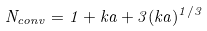Convert formula to latex. <formula><loc_0><loc_0><loc_500><loc_500>N _ { c o n v } = 1 + k a + 3 ( k a ) ^ { 1 / 3 }</formula> 